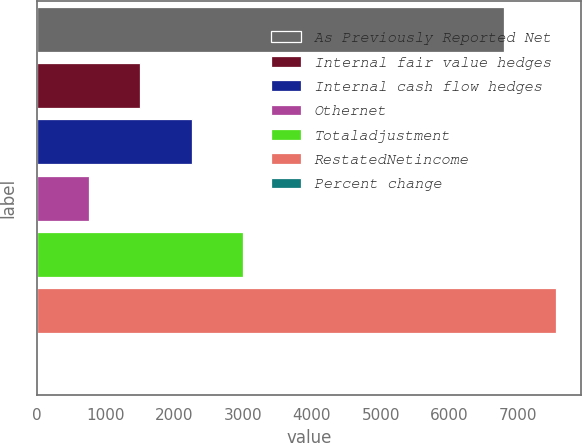Convert chart. <chart><loc_0><loc_0><loc_500><loc_500><bar_chart><fcel>As Previously Reported Net<fcel>Internal fair value hedges<fcel>Internal cash flow hedges<fcel>Othernet<fcel>Totaladjustment<fcel>RestatedNetincome<fcel>Percent change<nl><fcel>6792<fcel>1508.12<fcel>2256.98<fcel>759.26<fcel>3005.84<fcel>7540.86<fcel>10.4<nl></chart> 